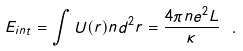Convert formula to latex. <formula><loc_0><loc_0><loc_500><loc_500>E _ { i n t } = \int U ( r ) n d ^ { 2 } r = \frac { 4 \pi n e ^ { 2 } L } { \kappa } \ .</formula> 